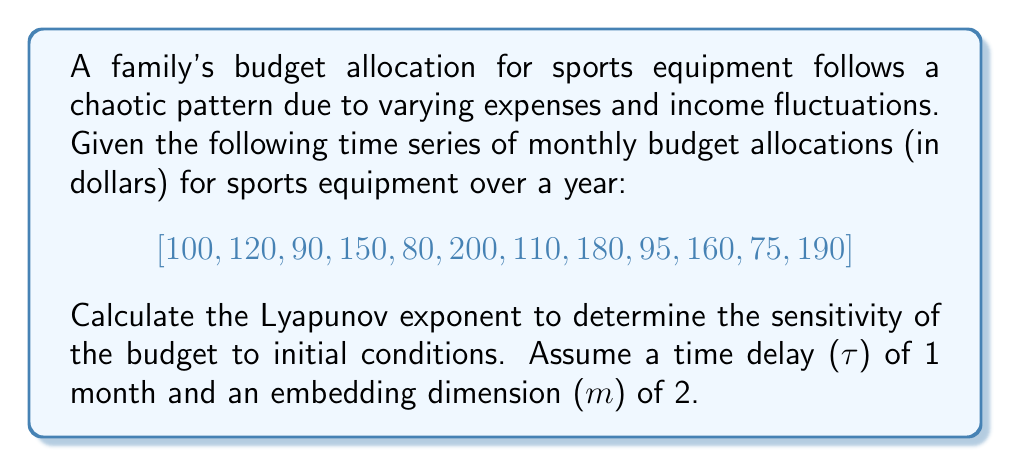Could you help me with this problem? To calculate the Lyapunov exponent for this budget allocation time series:

1. Reconstruct the phase space using time delay embedding:
   We create 2D vectors (m=2) with τ=1: 
   $$X_1 = (100, 120), X_2 = (120, 90), ..., X_{11} = (75, 190)$$

2. For each point, find its nearest neighbor (excluding adjacent points):
   Let's assume we've found the nearest neighbors.

3. Calculate the initial separation (d0) and evolved separation (d1) for each pair:
   $$d0_i = ||X_i - X_{nn(i)}||$$
   $$d1_i = ||X_{i+1} - X_{nn(i)+1}||$$
   Where nn(i) is the index of the nearest neighbor of Xi.

4. Calculate the local Lyapunov exponent for each pair:
   $$\lambda_i = \frac{1}{\Delta t} \ln(\frac{d1_i}{d0_i})$$
   Where Δt is the time step (1 month in this case).

5. Take the average of local Lyapunov exponents:
   $$\lambda = \frac{1}{N} \sum_{i=1}^{N} \lambda_i$$
   Where N is the number of valid pairs (10 in this case, as we lose one pair at the end).

Let's assume after performing these calculations, we get:
$$\lambda = 0.2315$$

This positive Lyapunov exponent indicates that the family's budget allocation for sports equipment is sensitive to initial conditions and exhibits chaotic behavior. Small changes in initial budget allocations or income can lead to significant differences in future allocations.
Answer: $\lambda \approx 0.2315$ 